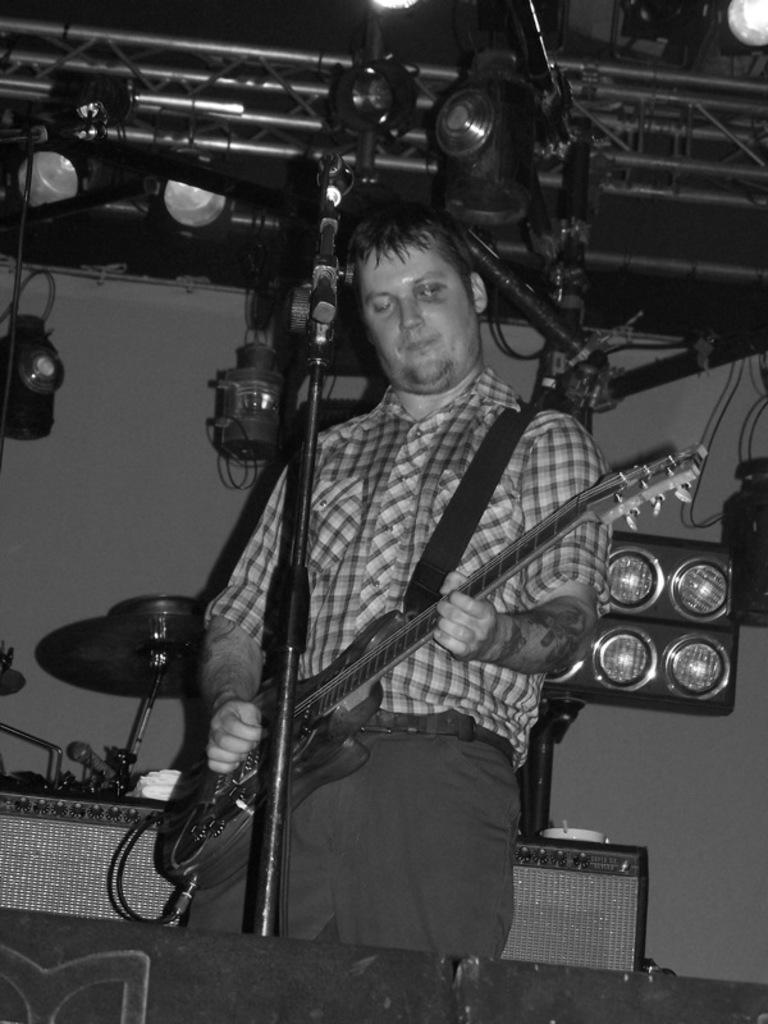How would you summarize this image in a sentence or two? This picture is taken in a room. The picture is in black and white. There is a man playing a guitar, he is wearing a check shirt and trousers. In the background there are group of lights, musical instrument and chair. 